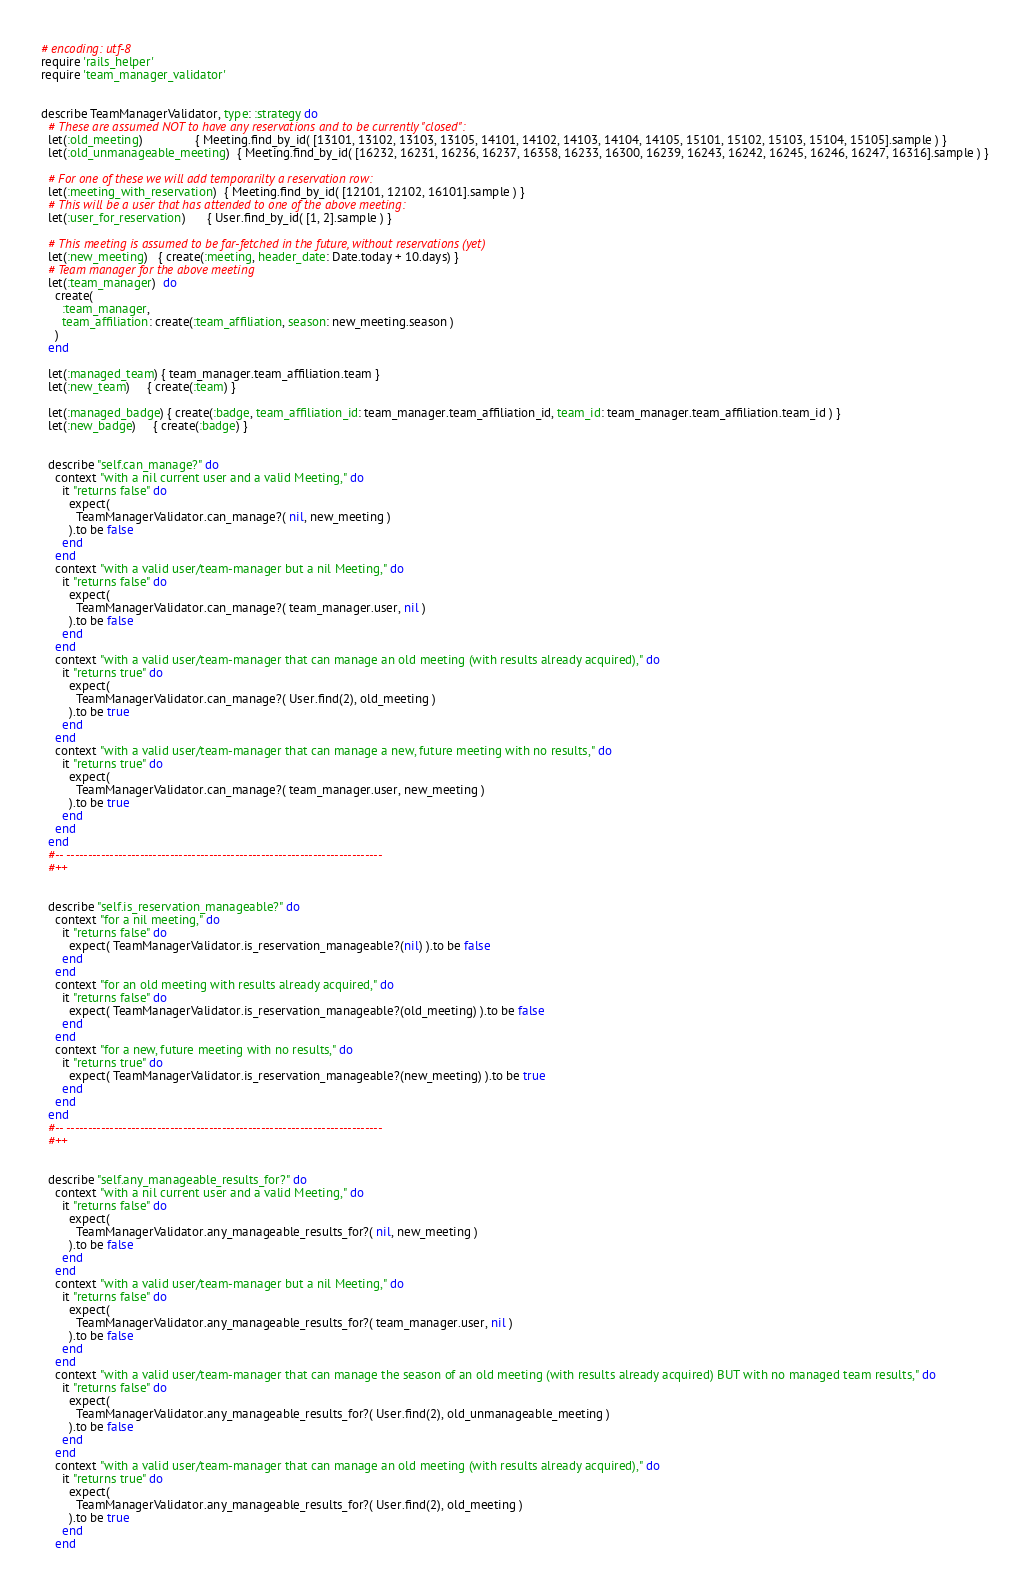Convert code to text. <code><loc_0><loc_0><loc_500><loc_500><_Ruby_># encoding: utf-8
require 'rails_helper'
require 'team_manager_validator'


describe TeamManagerValidator, type: :strategy do
  # These are assumed NOT to have any reservations and to be currently "closed":
  let(:old_meeting)               { Meeting.find_by_id( [13101, 13102, 13103, 13105, 14101, 14102, 14103, 14104, 14105, 15101, 15102, 15103, 15104, 15105].sample ) }
  let(:old_unmanageable_meeting)  { Meeting.find_by_id( [16232, 16231, 16236, 16237, 16358, 16233, 16300, 16239, 16243, 16242, 16245, 16246, 16247, 16316].sample ) }

  # For one of these we will add temporarilty a reservation row:
  let(:meeting_with_reservation)  { Meeting.find_by_id( [12101, 12102, 16101].sample ) }
  # This will be a user that has attended to one of the above meeting:
  let(:user_for_reservation)      { User.find_by_id( [1, 2].sample ) }

  # This meeting is assumed to be far-fetched in the future, without reservations (yet)
  let(:new_meeting)   { create(:meeting, header_date: Date.today + 10.days) }
  # Team manager for the above meeting
  let(:team_manager)  do
    create(
      :team_manager,
      team_affiliation: create(:team_affiliation, season: new_meeting.season )
    )
  end

  let(:managed_team) { team_manager.team_affiliation.team }
  let(:new_team)     { create(:team) }

  let(:managed_badge) { create(:badge, team_affiliation_id: team_manager.team_affiliation_id, team_id: team_manager.team_affiliation.team_id ) }
  let(:new_badge)     { create(:badge) }


  describe "self.can_manage?" do
    context "with a nil current user and a valid Meeting," do
      it "returns false" do
        expect(
          TeamManagerValidator.can_manage?( nil, new_meeting )
        ).to be false
      end
    end
    context "with a valid user/team-manager but a nil Meeting," do
      it "returns false" do
        expect(
          TeamManagerValidator.can_manage?( team_manager.user, nil )
        ).to be false
      end
    end
    context "with a valid user/team-manager that can manage an old meeting (with results already acquired)," do
      it "returns true" do
        expect(
          TeamManagerValidator.can_manage?( User.find(2), old_meeting )
        ).to be true
      end
    end
    context "with a valid user/team-manager that can manage a new, future meeting with no results," do
      it "returns true" do
        expect(
          TeamManagerValidator.can_manage?( team_manager.user, new_meeting )
        ).to be true
      end
    end
  end
  #-- -------------------------------------------------------------------------
  #++


  describe "self.is_reservation_manageable?" do
    context "for a nil meeting," do
      it "returns false" do
        expect( TeamManagerValidator.is_reservation_manageable?(nil) ).to be false
      end
    end
    context "for an old meeting with results already acquired," do
      it "returns false" do
        expect( TeamManagerValidator.is_reservation_manageable?(old_meeting) ).to be false
      end
    end
    context "for a new, future meeting with no results," do
      it "returns true" do
        expect( TeamManagerValidator.is_reservation_manageable?(new_meeting) ).to be true
      end
    end
  end
  #-- -------------------------------------------------------------------------
  #++


  describe "self.any_manageable_results_for?" do
    context "with a nil current user and a valid Meeting," do
      it "returns false" do
        expect(
          TeamManagerValidator.any_manageable_results_for?( nil, new_meeting )
        ).to be false
      end
    end
    context "with a valid user/team-manager but a nil Meeting," do
      it "returns false" do
        expect(
          TeamManagerValidator.any_manageable_results_for?( team_manager.user, nil )
        ).to be false
      end
    end
    context "with a valid user/team-manager that can manage the season of an old meeting (with results already acquired) BUT with no managed team results," do
      it "returns false" do
        expect(
          TeamManagerValidator.any_manageable_results_for?( User.find(2), old_unmanageable_meeting )
        ).to be false
      end
    end
    context "with a valid user/team-manager that can manage an old meeting (with results already acquired)," do
      it "returns true" do
        expect(
          TeamManagerValidator.any_manageable_results_for?( User.find(2), old_meeting )
        ).to be true
      end
    end</code> 